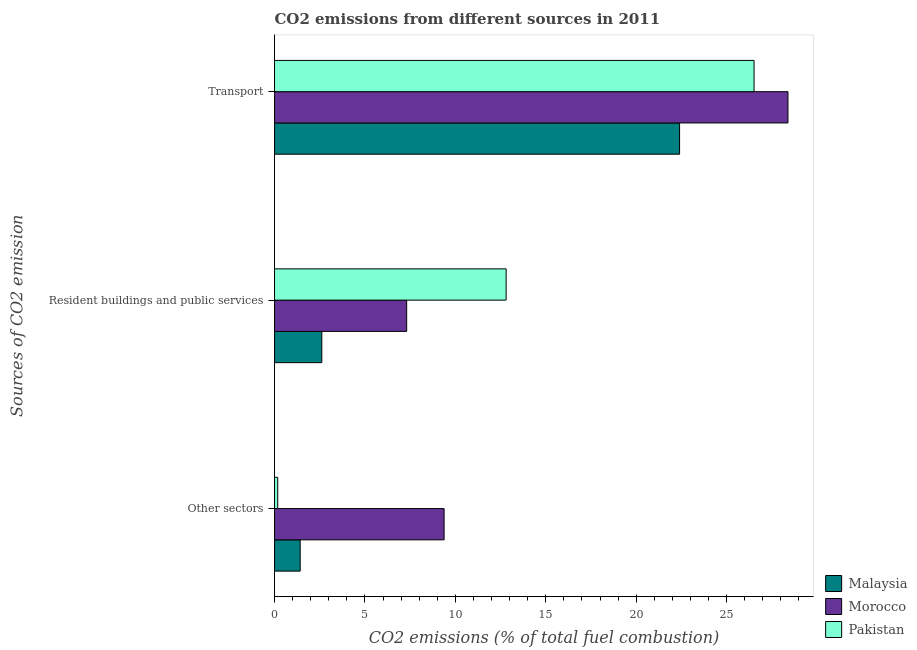How many groups of bars are there?
Give a very brief answer. 3. Are the number of bars per tick equal to the number of legend labels?
Your response must be concise. Yes. Are the number of bars on each tick of the Y-axis equal?
Your response must be concise. Yes. What is the label of the 3rd group of bars from the top?
Offer a terse response. Other sectors. What is the percentage of co2 emissions from transport in Pakistan?
Give a very brief answer. 26.52. Across all countries, what is the maximum percentage of co2 emissions from resident buildings and public services?
Provide a short and direct response. 12.81. Across all countries, what is the minimum percentage of co2 emissions from resident buildings and public services?
Your answer should be compact. 2.61. In which country was the percentage of co2 emissions from other sectors maximum?
Your answer should be compact. Morocco. In which country was the percentage of co2 emissions from other sectors minimum?
Your response must be concise. Pakistan. What is the total percentage of co2 emissions from resident buildings and public services in the graph?
Make the answer very short. 22.73. What is the difference between the percentage of co2 emissions from other sectors in Pakistan and that in Morocco?
Offer a terse response. -9.2. What is the difference between the percentage of co2 emissions from other sectors in Malaysia and the percentage of co2 emissions from transport in Pakistan?
Ensure brevity in your answer.  -25.1. What is the average percentage of co2 emissions from resident buildings and public services per country?
Provide a succinct answer. 7.58. What is the difference between the percentage of co2 emissions from resident buildings and public services and percentage of co2 emissions from other sectors in Pakistan?
Your answer should be compact. 12.63. What is the ratio of the percentage of co2 emissions from other sectors in Pakistan to that in Morocco?
Give a very brief answer. 0.02. Is the percentage of co2 emissions from resident buildings and public services in Morocco less than that in Pakistan?
Ensure brevity in your answer.  Yes. Is the difference between the percentage of co2 emissions from transport in Morocco and Pakistan greater than the difference between the percentage of co2 emissions from other sectors in Morocco and Pakistan?
Give a very brief answer. No. What is the difference between the highest and the second highest percentage of co2 emissions from transport?
Provide a succinct answer. 1.88. What is the difference between the highest and the lowest percentage of co2 emissions from other sectors?
Your answer should be very brief. 9.2. In how many countries, is the percentage of co2 emissions from resident buildings and public services greater than the average percentage of co2 emissions from resident buildings and public services taken over all countries?
Provide a succinct answer. 1. Is the sum of the percentage of co2 emissions from other sectors in Pakistan and Malaysia greater than the maximum percentage of co2 emissions from resident buildings and public services across all countries?
Provide a succinct answer. No. What does the 2nd bar from the top in Other sectors represents?
Provide a short and direct response. Morocco. Are all the bars in the graph horizontal?
Your answer should be compact. Yes. Are the values on the major ticks of X-axis written in scientific E-notation?
Provide a short and direct response. No. Does the graph contain any zero values?
Offer a very short reply. No. Where does the legend appear in the graph?
Provide a succinct answer. Bottom right. How are the legend labels stacked?
Offer a very short reply. Vertical. What is the title of the graph?
Provide a short and direct response. CO2 emissions from different sources in 2011. What is the label or title of the X-axis?
Keep it short and to the point. CO2 emissions (% of total fuel combustion). What is the label or title of the Y-axis?
Provide a short and direct response. Sources of CO2 emission. What is the CO2 emissions (% of total fuel combustion) of Malaysia in Other sectors?
Keep it short and to the point. 1.42. What is the CO2 emissions (% of total fuel combustion) of Morocco in Other sectors?
Offer a terse response. 9.38. What is the CO2 emissions (% of total fuel combustion) of Pakistan in Other sectors?
Your answer should be compact. 0.18. What is the CO2 emissions (% of total fuel combustion) of Malaysia in Resident buildings and public services?
Make the answer very short. 2.61. What is the CO2 emissions (% of total fuel combustion) in Morocco in Resident buildings and public services?
Make the answer very short. 7.31. What is the CO2 emissions (% of total fuel combustion) in Pakistan in Resident buildings and public services?
Your answer should be compact. 12.81. What is the CO2 emissions (% of total fuel combustion) of Malaysia in Transport?
Offer a terse response. 22.4. What is the CO2 emissions (% of total fuel combustion) of Morocco in Transport?
Offer a very short reply. 28.4. What is the CO2 emissions (% of total fuel combustion) of Pakistan in Transport?
Keep it short and to the point. 26.52. Across all Sources of CO2 emission, what is the maximum CO2 emissions (% of total fuel combustion) of Malaysia?
Offer a terse response. 22.4. Across all Sources of CO2 emission, what is the maximum CO2 emissions (% of total fuel combustion) of Morocco?
Ensure brevity in your answer.  28.4. Across all Sources of CO2 emission, what is the maximum CO2 emissions (% of total fuel combustion) of Pakistan?
Ensure brevity in your answer.  26.52. Across all Sources of CO2 emission, what is the minimum CO2 emissions (% of total fuel combustion) of Malaysia?
Ensure brevity in your answer.  1.42. Across all Sources of CO2 emission, what is the minimum CO2 emissions (% of total fuel combustion) of Morocco?
Offer a terse response. 7.31. Across all Sources of CO2 emission, what is the minimum CO2 emissions (% of total fuel combustion) in Pakistan?
Ensure brevity in your answer.  0.18. What is the total CO2 emissions (% of total fuel combustion) of Malaysia in the graph?
Your answer should be very brief. 26.43. What is the total CO2 emissions (% of total fuel combustion) in Morocco in the graph?
Keep it short and to the point. 45.08. What is the total CO2 emissions (% of total fuel combustion) in Pakistan in the graph?
Offer a terse response. 39.5. What is the difference between the CO2 emissions (% of total fuel combustion) of Malaysia in Other sectors and that in Resident buildings and public services?
Your response must be concise. -1.2. What is the difference between the CO2 emissions (% of total fuel combustion) of Morocco in Other sectors and that in Resident buildings and public services?
Your response must be concise. 2.07. What is the difference between the CO2 emissions (% of total fuel combustion) in Pakistan in Other sectors and that in Resident buildings and public services?
Ensure brevity in your answer.  -12.63. What is the difference between the CO2 emissions (% of total fuel combustion) in Malaysia in Other sectors and that in Transport?
Provide a short and direct response. -20.98. What is the difference between the CO2 emissions (% of total fuel combustion) of Morocco in Other sectors and that in Transport?
Keep it short and to the point. -19.02. What is the difference between the CO2 emissions (% of total fuel combustion) in Pakistan in Other sectors and that in Transport?
Offer a very short reply. -26.34. What is the difference between the CO2 emissions (% of total fuel combustion) in Malaysia in Resident buildings and public services and that in Transport?
Your answer should be very brief. -19.79. What is the difference between the CO2 emissions (% of total fuel combustion) in Morocco in Resident buildings and public services and that in Transport?
Give a very brief answer. -21.09. What is the difference between the CO2 emissions (% of total fuel combustion) of Pakistan in Resident buildings and public services and that in Transport?
Keep it short and to the point. -13.71. What is the difference between the CO2 emissions (% of total fuel combustion) in Malaysia in Other sectors and the CO2 emissions (% of total fuel combustion) in Morocco in Resident buildings and public services?
Your answer should be compact. -5.89. What is the difference between the CO2 emissions (% of total fuel combustion) in Malaysia in Other sectors and the CO2 emissions (% of total fuel combustion) in Pakistan in Resident buildings and public services?
Provide a short and direct response. -11.39. What is the difference between the CO2 emissions (% of total fuel combustion) of Morocco in Other sectors and the CO2 emissions (% of total fuel combustion) of Pakistan in Resident buildings and public services?
Provide a succinct answer. -3.43. What is the difference between the CO2 emissions (% of total fuel combustion) of Malaysia in Other sectors and the CO2 emissions (% of total fuel combustion) of Morocco in Transport?
Offer a terse response. -26.98. What is the difference between the CO2 emissions (% of total fuel combustion) of Malaysia in Other sectors and the CO2 emissions (% of total fuel combustion) of Pakistan in Transport?
Provide a short and direct response. -25.1. What is the difference between the CO2 emissions (% of total fuel combustion) of Morocco in Other sectors and the CO2 emissions (% of total fuel combustion) of Pakistan in Transport?
Give a very brief answer. -17.14. What is the difference between the CO2 emissions (% of total fuel combustion) in Malaysia in Resident buildings and public services and the CO2 emissions (% of total fuel combustion) in Morocco in Transport?
Offer a very short reply. -25.78. What is the difference between the CO2 emissions (% of total fuel combustion) in Malaysia in Resident buildings and public services and the CO2 emissions (% of total fuel combustion) in Pakistan in Transport?
Your answer should be very brief. -23.9. What is the difference between the CO2 emissions (% of total fuel combustion) of Morocco in Resident buildings and public services and the CO2 emissions (% of total fuel combustion) of Pakistan in Transport?
Ensure brevity in your answer.  -19.21. What is the average CO2 emissions (% of total fuel combustion) in Malaysia per Sources of CO2 emission?
Your answer should be very brief. 8.81. What is the average CO2 emissions (% of total fuel combustion) of Morocco per Sources of CO2 emission?
Offer a very short reply. 15.03. What is the average CO2 emissions (% of total fuel combustion) in Pakistan per Sources of CO2 emission?
Give a very brief answer. 13.17. What is the difference between the CO2 emissions (% of total fuel combustion) in Malaysia and CO2 emissions (% of total fuel combustion) in Morocco in Other sectors?
Offer a very short reply. -7.96. What is the difference between the CO2 emissions (% of total fuel combustion) in Malaysia and CO2 emissions (% of total fuel combustion) in Pakistan in Other sectors?
Provide a succinct answer. 1.24. What is the difference between the CO2 emissions (% of total fuel combustion) of Morocco and CO2 emissions (% of total fuel combustion) of Pakistan in Other sectors?
Ensure brevity in your answer.  9.2. What is the difference between the CO2 emissions (% of total fuel combustion) of Malaysia and CO2 emissions (% of total fuel combustion) of Morocco in Resident buildings and public services?
Keep it short and to the point. -4.69. What is the difference between the CO2 emissions (% of total fuel combustion) of Malaysia and CO2 emissions (% of total fuel combustion) of Pakistan in Resident buildings and public services?
Your answer should be very brief. -10.19. What is the difference between the CO2 emissions (% of total fuel combustion) in Morocco and CO2 emissions (% of total fuel combustion) in Pakistan in Resident buildings and public services?
Offer a very short reply. -5.5. What is the difference between the CO2 emissions (% of total fuel combustion) in Malaysia and CO2 emissions (% of total fuel combustion) in Morocco in Transport?
Ensure brevity in your answer.  -5.99. What is the difference between the CO2 emissions (% of total fuel combustion) of Malaysia and CO2 emissions (% of total fuel combustion) of Pakistan in Transport?
Make the answer very short. -4.12. What is the difference between the CO2 emissions (% of total fuel combustion) of Morocco and CO2 emissions (% of total fuel combustion) of Pakistan in Transport?
Ensure brevity in your answer.  1.88. What is the ratio of the CO2 emissions (% of total fuel combustion) in Malaysia in Other sectors to that in Resident buildings and public services?
Provide a succinct answer. 0.54. What is the ratio of the CO2 emissions (% of total fuel combustion) in Morocco in Other sectors to that in Resident buildings and public services?
Provide a succinct answer. 1.28. What is the ratio of the CO2 emissions (% of total fuel combustion) of Pakistan in Other sectors to that in Resident buildings and public services?
Provide a short and direct response. 0.01. What is the ratio of the CO2 emissions (% of total fuel combustion) of Malaysia in Other sectors to that in Transport?
Your answer should be very brief. 0.06. What is the ratio of the CO2 emissions (% of total fuel combustion) of Morocco in Other sectors to that in Transport?
Your answer should be very brief. 0.33. What is the ratio of the CO2 emissions (% of total fuel combustion) of Pakistan in Other sectors to that in Transport?
Give a very brief answer. 0.01. What is the ratio of the CO2 emissions (% of total fuel combustion) of Malaysia in Resident buildings and public services to that in Transport?
Provide a succinct answer. 0.12. What is the ratio of the CO2 emissions (% of total fuel combustion) in Morocco in Resident buildings and public services to that in Transport?
Keep it short and to the point. 0.26. What is the ratio of the CO2 emissions (% of total fuel combustion) in Pakistan in Resident buildings and public services to that in Transport?
Ensure brevity in your answer.  0.48. What is the difference between the highest and the second highest CO2 emissions (% of total fuel combustion) of Malaysia?
Offer a very short reply. 19.79. What is the difference between the highest and the second highest CO2 emissions (% of total fuel combustion) in Morocco?
Offer a very short reply. 19.02. What is the difference between the highest and the second highest CO2 emissions (% of total fuel combustion) of Pakistan?
Give a very brief answer. 13.71. What is the difference between the highest and the lowest CO2 emissions (% of total fuel combustion) of Malaysia?
Make the answer very short. 20.98. What is the difference between the highest and the lowest CO2 emissions (% of total fuel combustion) of Morocco?
Make the answer very short. 21.09. What is the difference between the highest and the lowest CO2 emissions (% of total fuel combustion) of Pakistan?
Give a very brief answer. 26.34. 